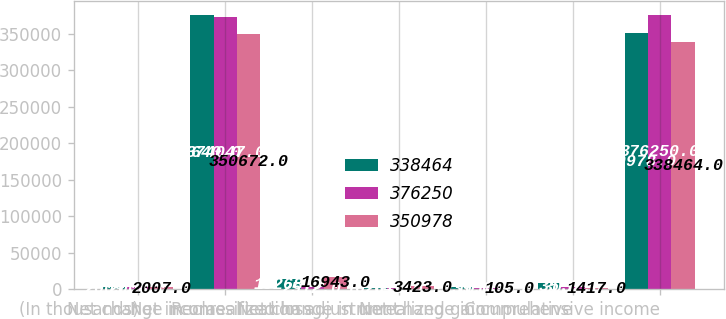Convert chart to OTSL. <chart><loc_0><loc_0><loc_500><loc_500><stacked_bar_chart><ecel><fcel>(In thousands)<fcel>Net income<fcel>Net change in unrealized loss<fcel>Reclassification adjustment<fcel>Net change in unrealized gain<fcel>Net change in cumulative<fcel>Comprehensive income<nl><fcel>338464<fcel>2009<fcel>375640<fcel>13268<fcel>1620<fcel>2039<fcel>7735<fcel>350978<nl><fcel>376250<fcel>2008<fcel>374047<fcel>2512<fcel>649<fcel>1014<fcel>3052<fcel>376250<nl><fcel>350978<fcel>2007<fcel>350672<fcel>16943<fcel>3423<fcel>105<fcel>1417<fcel>338464<nl></chart> 